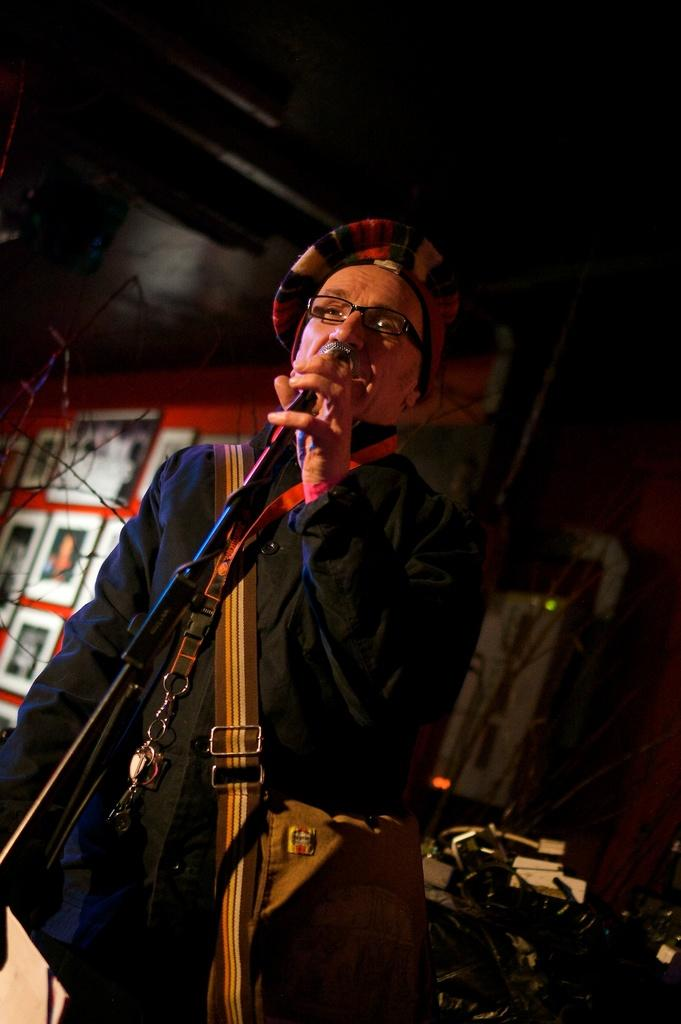What is the main subject of the image? There is a man in the image. What is the man holding in the image? The man is holding a microphone with a stand. Can you describe the objects behind the man? There are objects behind the man, but their specific details are not mentioned in the facts. What can be seen on the wall in the background? There is a wall with photo frames in the background. What type of pain is the man experiencing in the image? There is no indication in the image that the man is experiencing any pain. 